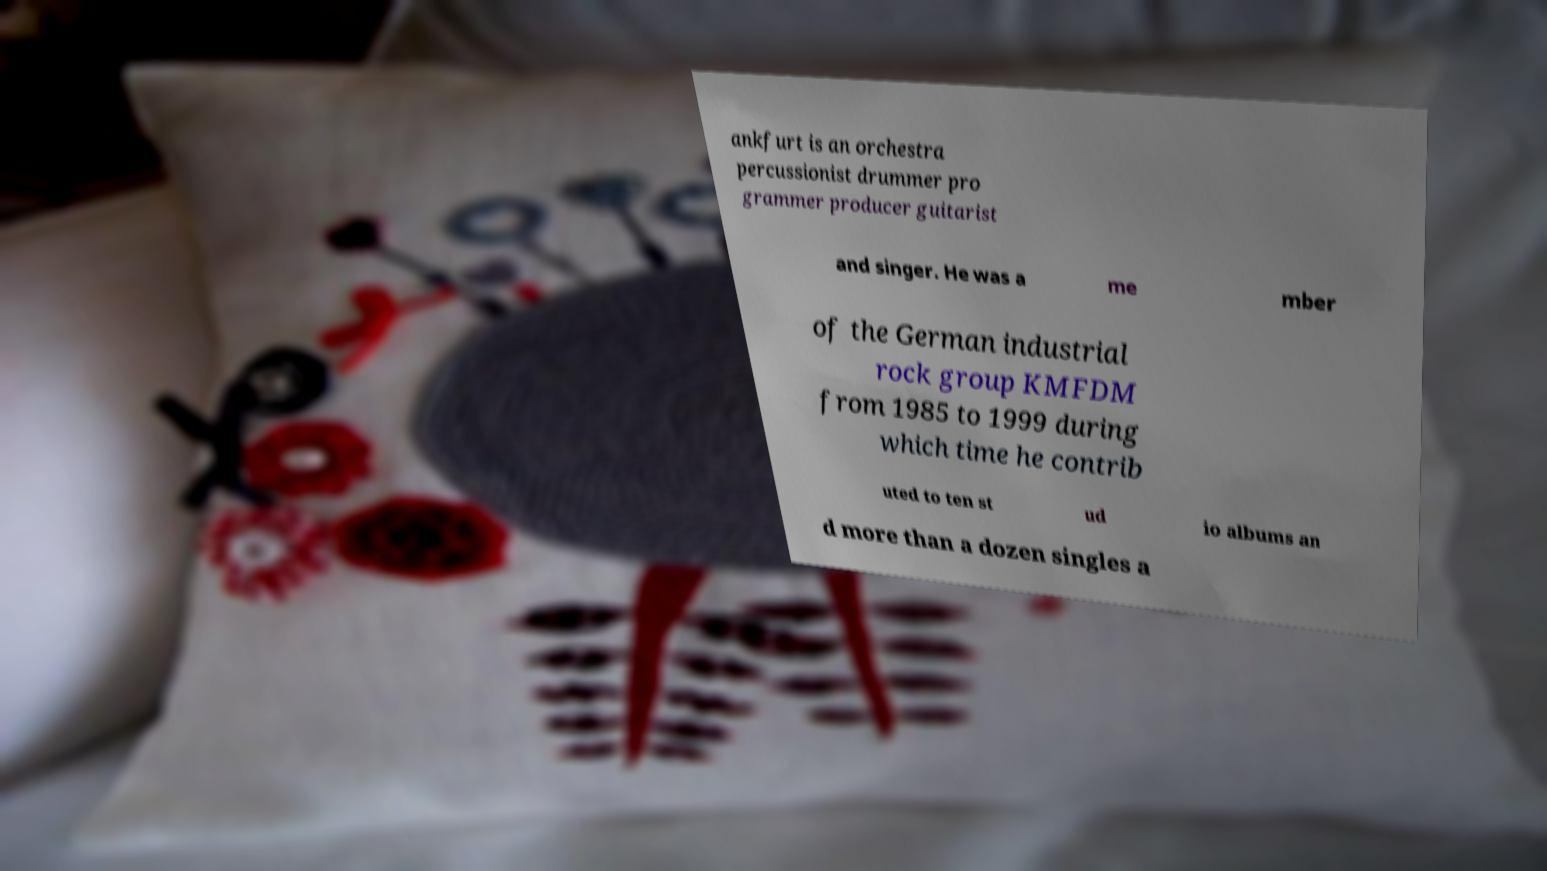There's text embedded in this image that I need extracted. Can you transcribe it verbatim? ankfurt is an orchestra percussionist drummer pro grammer producer guitarist and singer. He was a me mber of the German industrial rock group KMFDM from 1985 to 1999 during which time he contrib uted to ten st ud io albums an d more than a dozen singles a 